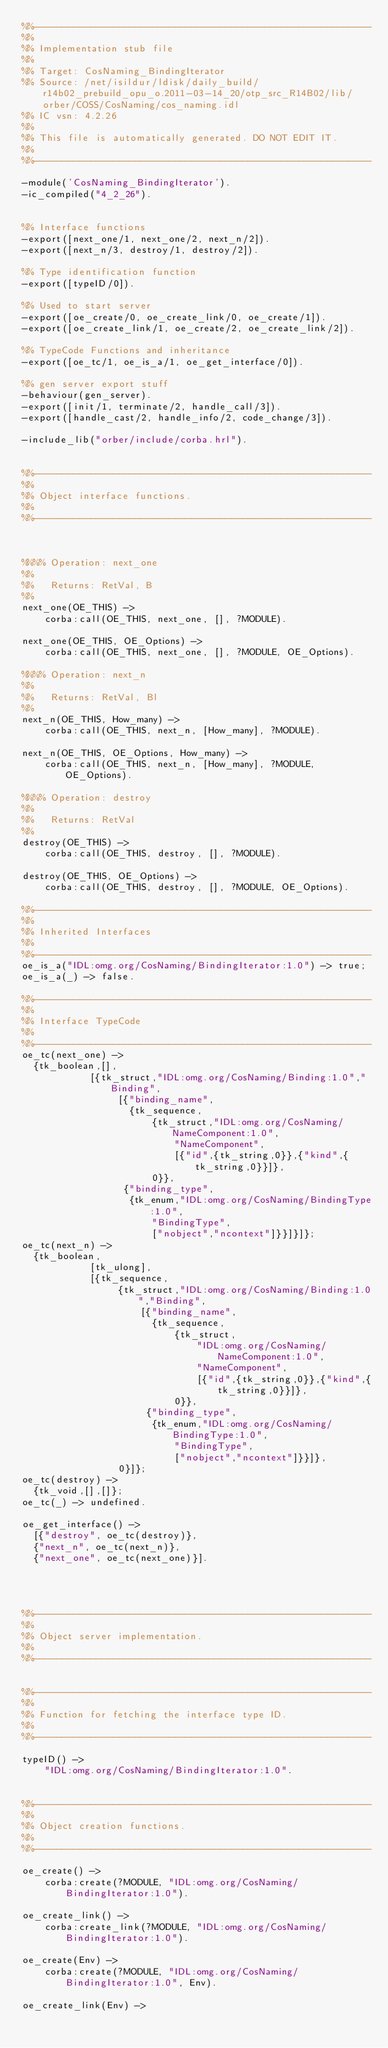<code> <loc_0><loc_0><loc_500><loc_500><_Erlang_>%%------------------------------------------------------------
%%
%% Implementation stub file
%% 
%% Target: CosNaming_BindingIterator
%% Source: /net/isildur/ldisk/daily_build/r14b02_prebuild_opu_o.2011-03-14_20/otp_src_R14B02/lib/orber/COSS/CosNaming/cos_naming.idl
%% IC vsn: 4.2.26
%% 
%% This file is automatically generated. DO NOT EDIT IT.
%%
%%------------------------------------------------------------

-module('CosNaming_BindingIterator').
-ic_compiled("4_2_26").


%% Interface functions
-export([next_one/1, next_one/2, next_n/2]).
-export([next_n/3, destroy/1, destroy/2]).

%% Type identification function
-export([typeID/0]).

%% Used to start server
-export([oe_create/0, oe_create_link/0, oe_create/1]).
-export([oe_create_link/1, oe_create/2, oe_create_link/2]).

%% TypeCode Functions and inheritance
-export([oe_tc/1, oe_is_a/1, oe_get_interface/0]).

%% gen server export stuff
-behaviour(gen_server).
-export([init/1, terminate/2, handle_call/3]).
-export([handle_cast/2, handle_info/2, code_change/3]).

-include_lib("orber/include/corba.hrl").


%%------------------------------------------------------------
%%
%% Object interface functions.
%%
%%------------------------------------------------------------



%%%% Operation: next_one
%% 
%%   Returns: RetVal, B
%%
next_one(OE_THIS) ->
    corba:call(OE_THIS, next_one, [], ?MODULE).

next_one(OE_THIS, OE_Options) ->
    corba:call(OE_THIS, next_one, [], ?MODULE, OE_Options).

%%%% Operation: next_n
%% 
%%   Returns: RetVal, Bl
%%
next_n(OE_THIS, How_many) ->
    corba:call(OE_THIS, next_n, [How_many], ?MODULE).

next_n(OE_THIS, OE_Options, How_many) ->
    corba:call(OE_THIS, next_n, [How_many], ?MODULE, OE_Options).

%%%% Operation: destroy
%% 
%%   Returns: RetVal
%%
destroy(OE_THIS) ->
    corba:call(OE_THIS, destroy, [], ?MODULE).

destroy(OE_THIS, OE_Options) ->
    corba:call(OE_THIS, destroy, [], ?MODULE, OE_Options).

%%------------------------------------------------------------
%%
%% Inherited Interfaces
%%
%%------------------------------------------------------------
oe_is_a("IDL:omg.org/CosNaming/BindingIterator:1.0") -> true;
oe_is_a(_) -> false.

%%------------------------------------------------------------
%%
%% Interface TypeCode
%%
%%------------------------------------------------------------
oe_tc(next_one) -> 
	{tk_boolean,[],
            [{tk_struct,"IDL:omg.org/CosNaming/Binding:1.0","Binding",
                 [{"binding_name",
                   {tk_sequence,
                       {tk_struct,"IDL:omg.org/CosNaming/NameComponent:1.0",
                           "NameComponent",
                           [{"id",{tk_string,0}},{"kind",{tk_string,0}}]},
                       0}},
                  {"binding_type",
                   {tk_enum,"IDL:omg.org/CosNaming/BindingType:1.0",
                       "BindingType",
                       ["nobject","ncontext"]}}]}]};
oe_tc(next_n) -> 
	{tk_boolean,
            [tk_ulong],
            [{tk_sequence,
                 {tk_struct,"IDL:omg.org/CosNaming/Binding:1.0","Binding",
                     [{"binding_name",
                       {tk_sequence,
                           {tk_struct,
                               "IDL:omg.org/CosNaming/NameComponent:1.0",
                               "NameComponent",
                               [{"id",{tk_string,0}},{"kind",{tk_string,0}}]},
                           0}},
                      {"binding_type",
                       {tk_enum,"IDL:omg.org/CosNaming/BindingType:1.0",
                           "BindingType",
                           ["nobject","ncontext"]}}]},
                 0}]};
oe_tc(destroy) -> 
	{tk_void,[],[]};
oe_tc(_) -> undefined.

oe_get_interface() -> 
	[{"destroy", oe_tc(destroy)},
	{"next_n", oe_tc(next_n)},
	{"next_one", oe_tc(next_one)}].




%%------------------------------------------------------------
%%
%% Object server implementation.
%%
%%------------------------------------------------------------


%%------------------------------------------------------------
%%
%% Function for fetching the interface type ID.
%%
%%------------------------------------------------------------

typeID() ->
    "IDL:omg.org/CosNaming/BindingIterator:1.0".


%%------------------------------------------------------------
%%
%% Object creation functions.
%%
%%------------------------------------------------------------

oe_create() ->
    corba:create(?MODULE, "IDL:omg.org/CosNaming/BindingIterator:1.0").

oe_create_link() ->
    corba:create_link(?MODULE, "IDL:omg.org/CosNaming/BindingIterator:1.0").

oe_create(Env) ->
    corba:create(?MODULE, "IDL:omg.org/CosNaming/BindingIterator:1.0", Env).

oe_create_link(Env) -></code> 